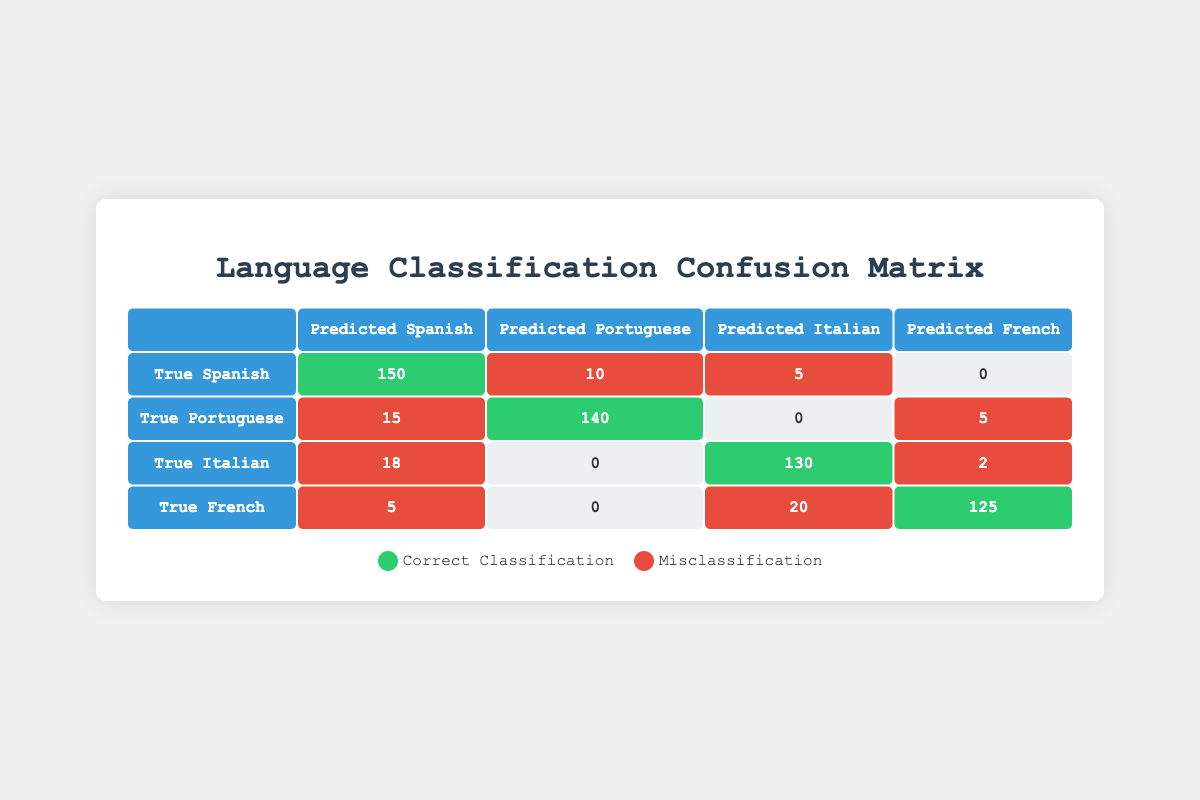What is the total number of correct classifications for Spanish? From the table, Spanish has 150 correct classifications (predicted as Spanish).
Answer: 150 What is the total number of false positives for Portuguese? To calculate false positives for Portuguese, we consider predictions of Portuguese when the true label is not Portuguese. Here, they are Spanish (15) and French (5), adding up to 15 + 5 = 20.
Answer: 20 Is the number of correct classifications for French greater than for Italian? The table shows French has 125 correct classifications and Italian has 130. Since 125 is less than 130, the statement is false.
Answer: No What is the total number of misclassifications for Italian? Misclassifications for Italian occur when Italian is predicted as Spanish (18), French (2), and none predicted as Portuguese. Adding these gives 18 + 2 = 20.
Answer: 20 Which language had the highest number of correct classifications? Looking at the diagonal values, Spanish has 150, Portuguese has 140, Italian has 130, and French has 125. The highest is Spanish with 150.
Answer: Spanish What is the total number of instances where French was misclassified? French was misclassified as Spanish (5) and Italian (20). Adding these values gives 5 + 20 = 25.
Answer: 25 What percentage of the total predictions made for Spanish were correct? The total predictions for Spanish are 150 correct (Spanish) and 15 (Portuguese) and 5 (Italian), totaling 150 + 15 + 5 = 170. Correct predictions are 150, so the percentage is (150/170) * 100 = 88.24%.
Answer: 88.24% How many instances in total were classified as Italian? Instances classified as Italian include correct (130) and those misclassified as Spanish (18) and French (2), totaling 130 + 18 + 2 = 150.
Answer: 150 What is the difference in misclassifications between Spanish and Portuguese? For Spanish, the misclassifications were to Portuguese (10) and Italian (5), totaling 10 + 5 = 15. For Portuguese, the misclassifications were to Spanish (15) and French (5), totaling 15 + 5 = 20. The difference is 20 - 15 = 5.
Answer: 5 